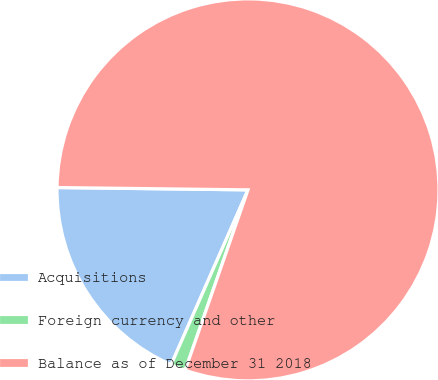<chart> <loc_0><loc_0><loc_500><loc_500><pie_chart><fcel>Acquisitions<fcel>Foreign currency and other<fcel>Balance as of December 31 2018<nl><fcel>18.6%<fcel>1.26%<fcel>80.14%<nl></chart> 